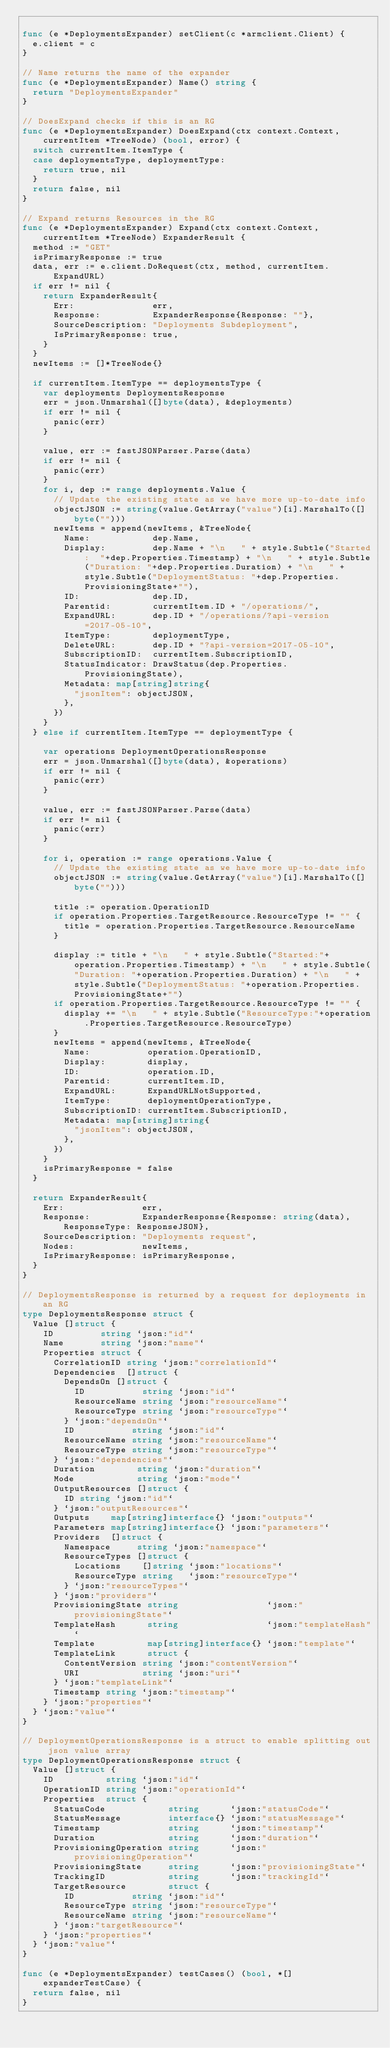<code> <loc_0><loc_0><loc_500><loc_500><_Go_>
func (e *DeploymentsExpander) setClient(c *armclient.Client) {
	e.client = c
}

// Name returns the name of the expander
func (e *DeploymentsExpander) Name() string {
	return "DeploymentsExpander"
}

// DoesExpand checks if this is an RG
func (e *DeploymentsExpander) DoesExpand(ctx context.Context, currentItem *TreeNode) (bool, error) {
	switch currentItem.ItemType {
	case deploymentsType, deploymentType:
		return true, nil
	}
	return false, nil
}

// Expand returns Resources in the RG
func (e *DeploymentsExpander) Expand(ctx context.Context, currentItem *TreeNode) ExpanderResult {
	method := "GET"
	isPrimaryResponse := true
	data, err := e.client.DoRequest(ctx, method, currentItem.ExpandURL)
	if err != nil {
		return ExpanderResult{
			Err:               err,
			Response:          ExpanderResponse{Response: ""},
			SourceDescription: "Deployments Subdeployment",
			IsPrimaryResponse: true,
		}
	}
	newItems := []*TreeNode{}

	if currentItem.ItemType == deploymentsType {
		var deployments DeploymentsResponse
		err = json.Unmarshal([]byte(data), &deployments)
		if err != nil {
			panic(err)
		}

		value, err := fastJSONParser.Parse(data)
		if err != nil {
			panic(err)
		}
		for i, dep := range deployments.Value {
			// Update the existing state as we have more up-to-date info
			objectJSON := string(value.GetArray("value")[i].MarshalTo([]byte("")))
			newItems = append(newItems, &TreeNode{
				Name:            dep.Name,
				Display:         dep.Name + "\n   " + style.Subtle("Started:  "+dep.Properties.Timestamp) + "\n   " + style.Subtle("Duration: "+dep.Properties.Duration) + "\n   " + style.Subtle("DeploymentStatus: "+dep.Properties.ProvisioningState+""),
				ID:              dep.ID,
				Parentid:        currentItem.ID + "/operations/",
				ExpandURL:       dep.ID + "/operations/?api-version=2017-05-10",
				ItemType:        deploymentType,
				DeleteURL:       dep.ID + "?api-version=2017-05-10",
				SubscriptionID:  currentItem.SubscriptionID,
				StatusIndicator: DrawStatus(dep.Properties.ProvisioningState),
				Metadata: map[string]string{
					"jsonItem": objectJSON,
				},
			})
		}
	} else if currentItem.ItemType == deploymentType {

		var operations DeploymentOperationsResponse
		err = json.Unmarshal([]byte(data), &operations)
		if err != nil {
			panic(err)
		}

		value, err := fastJSONParser.Parse(data)
		if err != nil {
			panic(err)
		}

		for i, operation := range operations.Value {
			// Update the existing state as we have more up-to-date info
			objectJSON := string(value.GetArray("value")[i].MarshalTo([]byte("")))

			title := operation.OperationID
			if operation.Properties.TargetResource.ResourceType != "" {
				title = operation.Properties.TargetResource.ResourceName
			}

			display := title + "\n   " + style.Subtle("Started:"+operation.Properties.Timestamp) + "\n   " + style.Subtle("Duration: "+operation.Properties.Duration) + "\n   " + style.Subtle("DeploymentStatus: "+operation.Properties.ProvisioningState+"")
			if operation.Properties.TargetResource.ResourceType != "" {
				display += "\n   " + style.Subtle("ResourceType:"+operation.Properties.TargetResource.ResourceType)
			}
			newItems = append(newItems, &TreeNode{
				Name:           operation.OperationID,
				Display:        display,
				ID:             operation.ID,
				Parentid:       currentItem.ID,
				ExpandURL:      ExpandURLNotSupported,
				ItemType:       deploymentOperationType,
				SubscriptionID: currentItem.SubscriptionID,
				Metadata: map[string]string{
					"jsonItem": objectJSON,
				},
			})
		}
		isPrimaryResponse = false
	}

	return ExpanderResult{
		Err:               err,
		Response:          ExpanderResponse{Response: string(data), ResponseType: ResponseJSON},
		SourceDescription: "Deployments request",
		Nodes:             newItems,
		IsPrimaryResponse: isPrimaryResponse,
	}
}

// DeploymentsResponse is returned by a request for deployments in an RG
type DeploymentsResponse struct {
	Value []struct {
		ID         string `json:"id"`
		Name       string `json:"name"`
		Properties struct {
			CorrelationID string `json:"correlationId"`
			Dependencies  []struct {
				DependsOn []struct {
					ID           string `json:"id"`
					ResourceName string `json:"resourceName"`
					ResourceType string `json:"resourceType"`
				} `json:"dependsOn"`
				ID           string `json:"id"`
				ResourceName string `json:"resourceName"`
				ResourceType string `json:"resourceType"`
			} `json:"dependencies"`
			Duration        string `json:"duration"`
			Mode            string `json:"mode"`
			OutputResources []struct {
				ID string `json:"id"`
			} `json:"outputResources"`
			Outputs    map[string]interface{} `json:"outputs"`
			Parameters map[string]interface{} `json:"parameters"`
			Providers  []struct {
				Namespace     string `json:"namespace"`
				ResourceTypes []struct {
					Locations    []string `json:"locations"`
					ResourceType string   `json:"resourceType"`
				} `json:"resourceTypes"`
			} `json:"providers"`
			ProvisioningState string                 `json:"provisioningState"`
			TemplateHash      string                 `json:"templateHash"`
			Template          map[string]interface{} `json:"template"`
			TemplateLink      struct {
				ContentVersion string `json:"contentVersion"`
				URI            string `json:"uri"`
			} `json:"templateLink"`
			Timestamp string `json:"timestamp"`
		} `json:"properties"`
	} `json:"value"`
}

// DeploymentOperationsResponse is a struct to enable splitting out json value array
type DeploymentOperationsResponse struct {
	Value []struct {
		ID          string `json:"id"`
		OperationID string `json:"operationId"`
		Properties  struct {
			StatusCode            string      `json:"statusCode"`
			StatusMessage         interface{} `json:"statusMessage"`
			Timestamp             string      `json:"timestamp"`
			Duration              string      `json:"duration"`
			ProvisioningOperation string      `json:"provisioningOperation"`
			ProvisioningState     string      `json:"provisioningState"`
			TrackingID            string      `json:"trackingId"`
			TargetResource        struct {
				ID           string `json:"id"`
				ResourceType string `json:"resourceType"`
				ResourceName string `json:"resourceName"`
			} `json:"targetResource"`
		} `json:"properties"`
	} `json:"value"`
}

func (e *DeploymentsExpander) testCases() (bool, *[]expanderTestCase) {
	return false, nil
}
</code> 